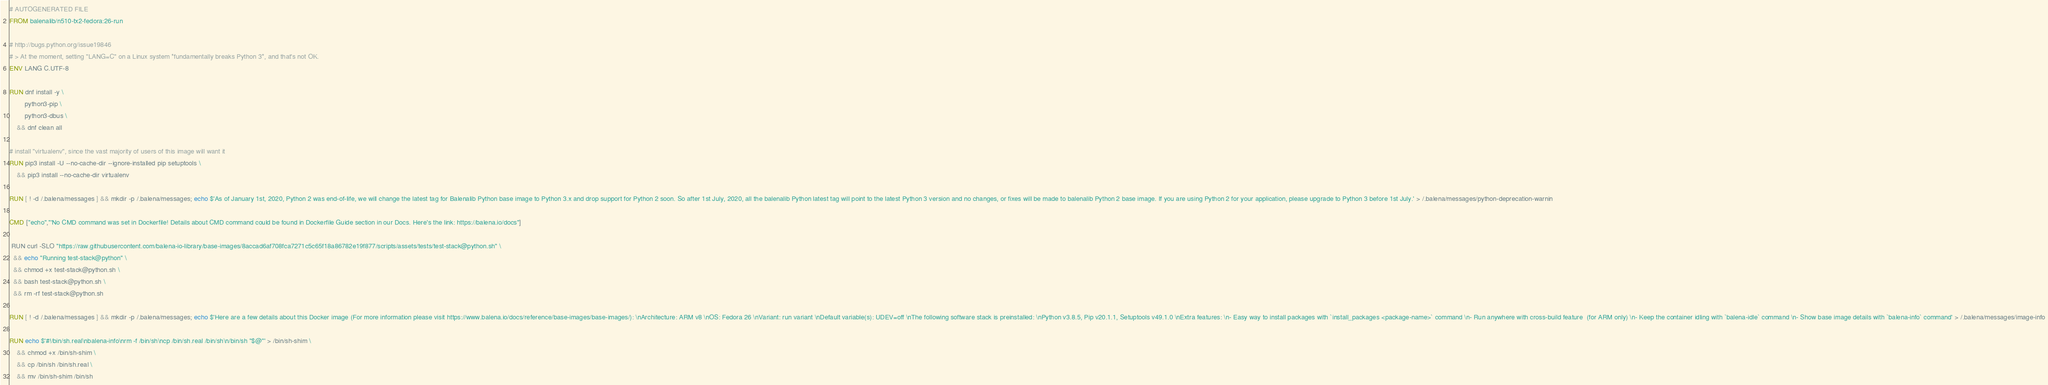<code> <loc_0><loc_0><loc_500><loc_500><_Dockerfile_># AUTOGENERATED FILE
FROM balenalib/n510-tx2-fedora:26-run

# http://bugs.python.org/issue19846
# > At the moment, setting "LANG=C" on a Linux system *fundamentally breaks Python 3*, and that's not OK.
ENV LANG C.UTF-8

RUN dnf install -y \
		python3-pip \
		python3-dbus \
	&& dnf clean all

# install "virtualenv", since the vast majority of users of this image will want it
RUN pip3 install -U --no-cache-dir --ignore-installed pip setuptools \
	&& pip3 install --no-cache-dir virtualenv

RUN [ ! -d /.balena/messages ] && mkdir -p /.balena/messages; echo $'As of January 1st, 2020, Python 2 was end-of-life, we will change the latest tag for Balenalib Python base image to Python 3.x and drop support for Python 2 soon. So after 1st July, 2020, all the balenalib Python latest tag will point to the latest Python 3 version and no changes, or fixes will be made to balenalib Python 2 base image. If you are using Python 2 for your application, please upgrade to Python 3 before 1st July.' > /.balena/messages/python-deprecation-warnin

CMD ["echo","'No CMD command was set in Dockerfile! Details about CMD command could be found in Dockerfile Guide section in our Docs. Here's the link: https://balena.io/docs"]

 RUN curl -SLO "https://raw.githubusercontent.com/balena-io-library/base-images/8accad6af708fca7271c5c65f18a86782e19f877/scripts/assets/tests/test-stack@python.sh" \
  && echo "Running test-stack@python" \
  && chmod +x test-stack@python.sh \
  && bash test-stack@python.sh \
  && rm -rf test-stack@python.sh 

RUN [ ! -d /.balena/messages ] && mkdir -p /.balena/messages; echo $'Here are a few details about this Docker image (For more information please visit https://www.balena.io/docs/reference/base-images/base-images/): \nArchitecture: ARM v8 \nOS: Fedora 26 \nVariant: run variant \nDefault variable(s): UDEV=off \nThe following software stack is preinstalled: \nPython v3.8.5, Pip v20.1.1, Setuptools v49.1.0 \nExtra features: \n- Easy way to install packages with `install_packages <package-name>` command \n- Run anywhere with cross-build feature  (for ARM only) \n- Keep the container idling with `balena-idle` command \n- Show base image details with `balena-info` command' > /.balena/messages/image-info

RUN echo $'#!/bin/sh.real\nbalena-info\nrm -f /bin/sh\ncp /bin/sh.real /bin/sh\n/bin/sh "$@"' > /bin/sh-shim \
	&& chmod +x /bin/sh-shim \
	&& cp /bin/sh /bin/sh.real \
	&& mv /bin/sh-shim /bin/sh</code> 